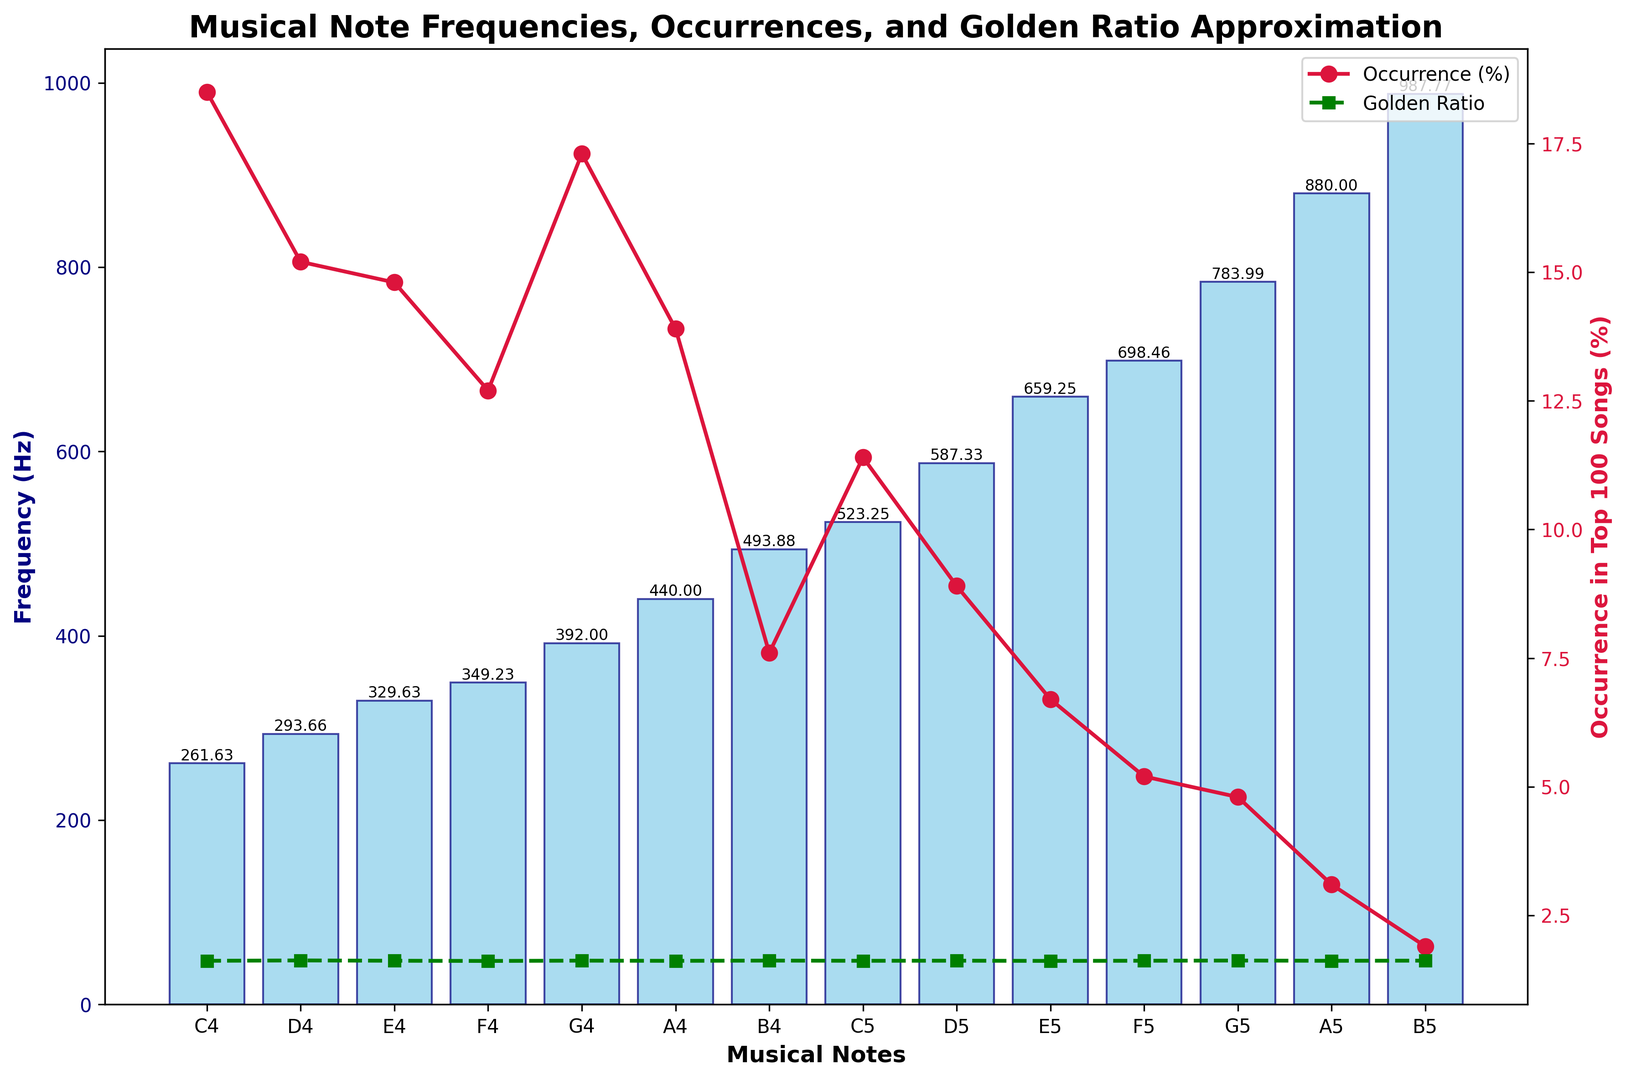What's the most frequently occurring note in popular songs? The line plot with red circles represents the occurrence in top 100 songs. By looking at the peaks of the line plot, we find that the note C4 with a frequency of 261.63 Hz has the highest occurrence percentage.
Answer: C4 Which musical note has the lowest occurrence in the top 100 songs? The line plot with red circles shows the occurrence percentage of musical notes. The note B5 with the occurrence percentage of 1.9% is the lowest.
Answer: B5 What is the difference in frequency between the notes C4 and B4? The frequency of C4 is 261.63 Hz and the frequency of B4 is 493.88 Hz. The difference is calculated as 493.88 - 261.63 = 232.25 Hz.
Answer: 232.25 Hz How does the frequency of A5 compare to that of A4? The frequency of A5 is 880 Hz while the frequency of A4 is 440 Hz. A5 has double the frequency of A4 since 880 is twice 440.
Answer: A5 is double A4 Which note has a golden ratio approximation closest to 1.618? By looking at the green dashed line with square markers, we find that several notes have a golden ratio approximation very close to 1.618. The notes C4, A4, C5, and A5 all have a golden ratio approximation of exactly 1.618.
Answer: C4, A4, C5, and A5 What's the average occurrence percentage of the notes C4, D4, and E4 in popular songs? Occurrence percentages: C4 = 18.5%, D4 = 15.2%, E4 = 14.8%. Average = (18.5 + 15.2 + 14.8) / 3 = 16.17%.
Answer: 16.17% How does the golden ratio approximation trend visually across the notes? The green dashed line shows that the golden ratio approximations are quite stable and clustered around 1.618 across all notes, with minor fluctuations.
Answer: Stable around 1.618 What are the total frequencies of F4 and F5 combined? The frequency of F4 is 349.23 Hz and the frequency of F5 is 698.46 Hz. The combined total is 349.23 + 698.46 = 1047.69 Hz.
Answer: 1047.69 Hz Which note has a higher frequency: G4 or G5? G5 has a frequency of 783.99 Hz, while G4 has a frequency of 392 Hz. Visually, the bar for G5 is much taller than that of G4.
Answer: G5 